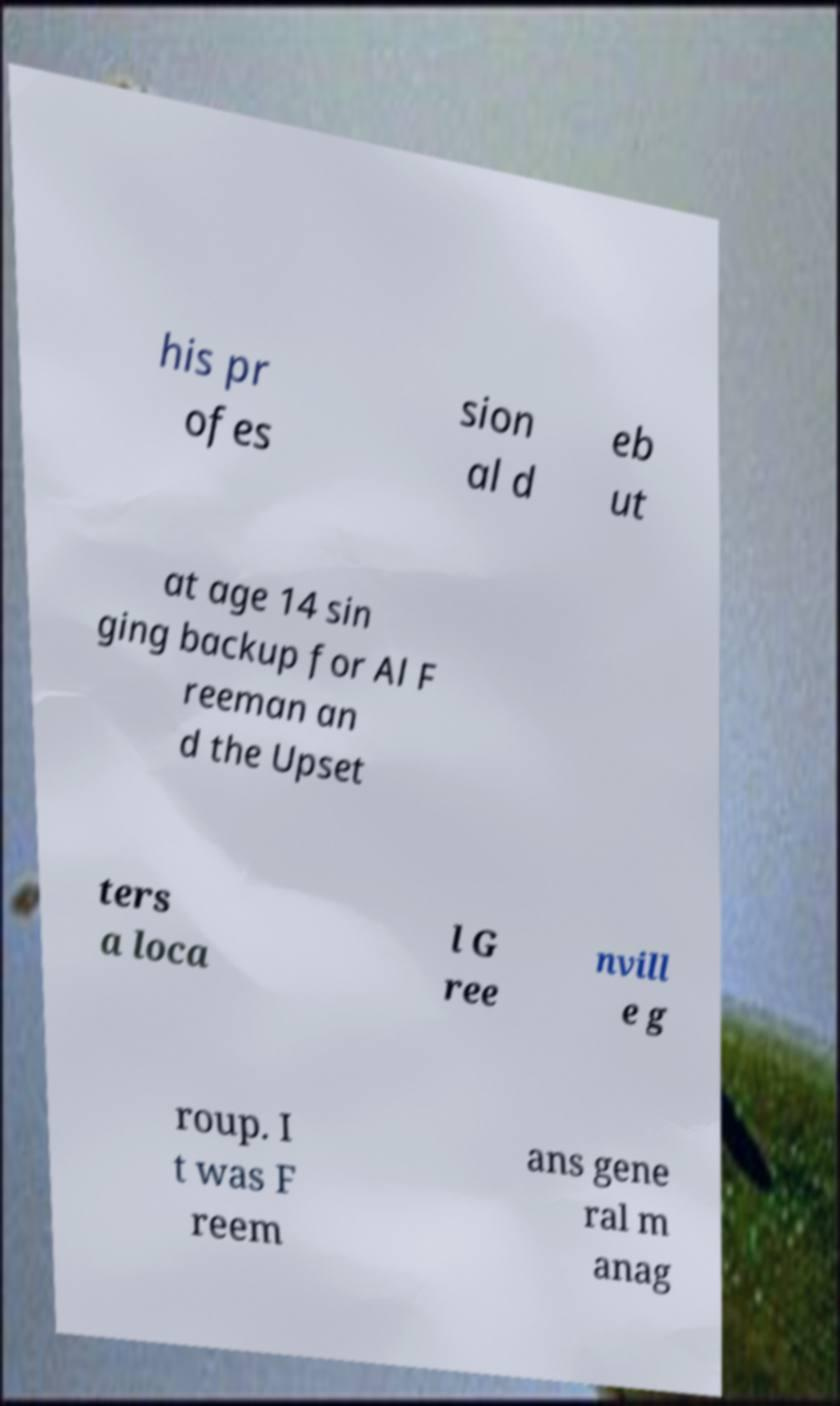What messages or text are displayed in this image? I need them in a readable, typed format. his pr ofes sion al d eb ut at age 14 sin ging backup for Al F reeman an d the Upset ters a loca l G ree nvill e g roup. I t was F reem ans gene ral m anag 